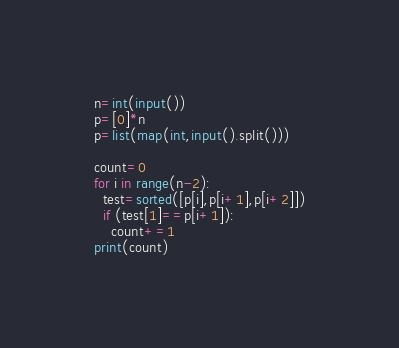<code> <loc_0><loc_0><loc_500><loc_500><_Python_>n=int(input())
p=[0]*n
p=list(map(int,input().split()))

count=0
for i in range(n-2):
  test=sorted([p[i],p[i+1],p[i+2]])
  if (test[1]==p[i+1]):
    count+=1
print(count)</code> 